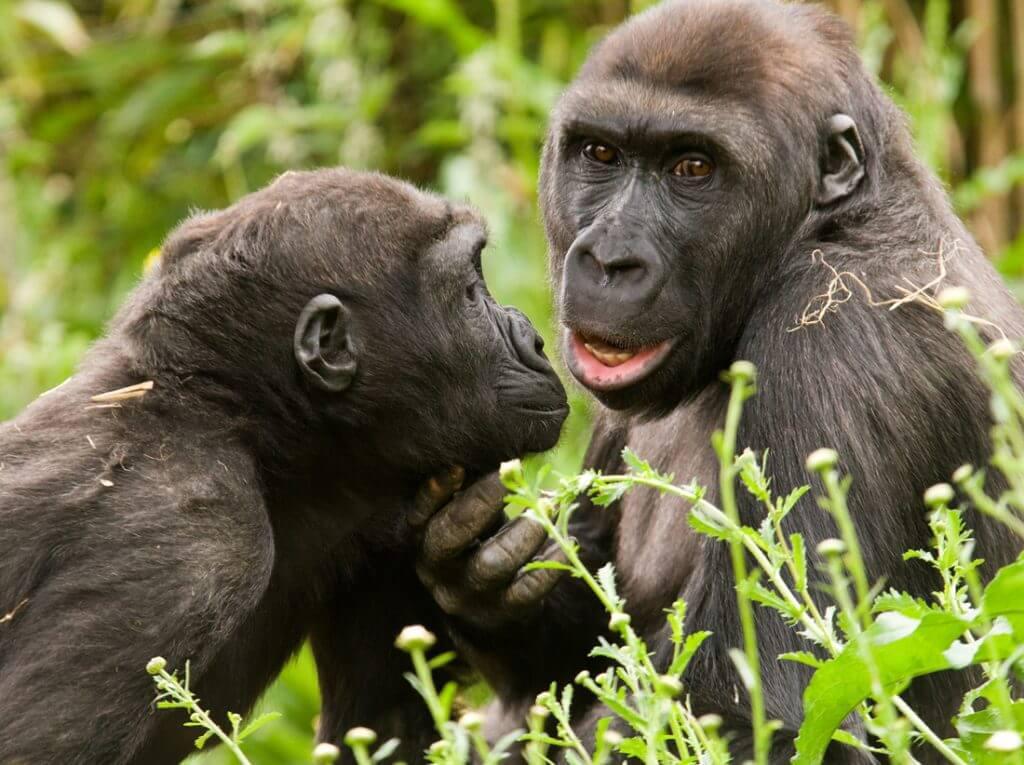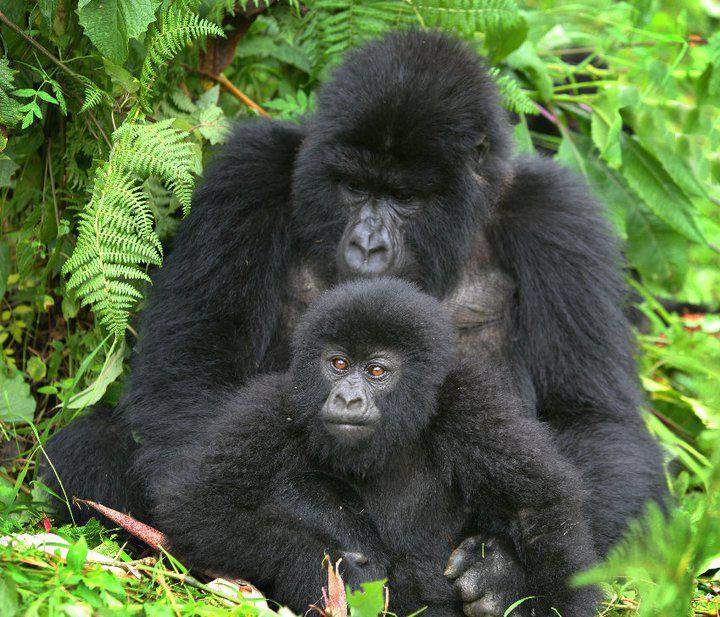The first image is the image on the left, the second image is the image on the right. Evaluate the accuracy of this statement regarding the images: "Left image shows a baby gorilla positioned in front of a sitting adult.". Is it true? Answer yes or no. No. 